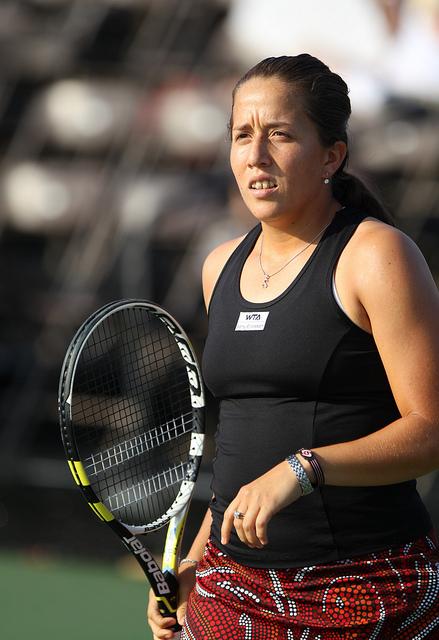What sport is the woman playing?
Give a very brief answer. Tennis. Is she facing the camera?
Be succinct. Yes. What is this woman wearing?
Concise answer only. Tank top. What is on her left wrist?
Write a very short answer. Bracelet. What brand tennis racket is she using?
Short answer required. Babolat. 